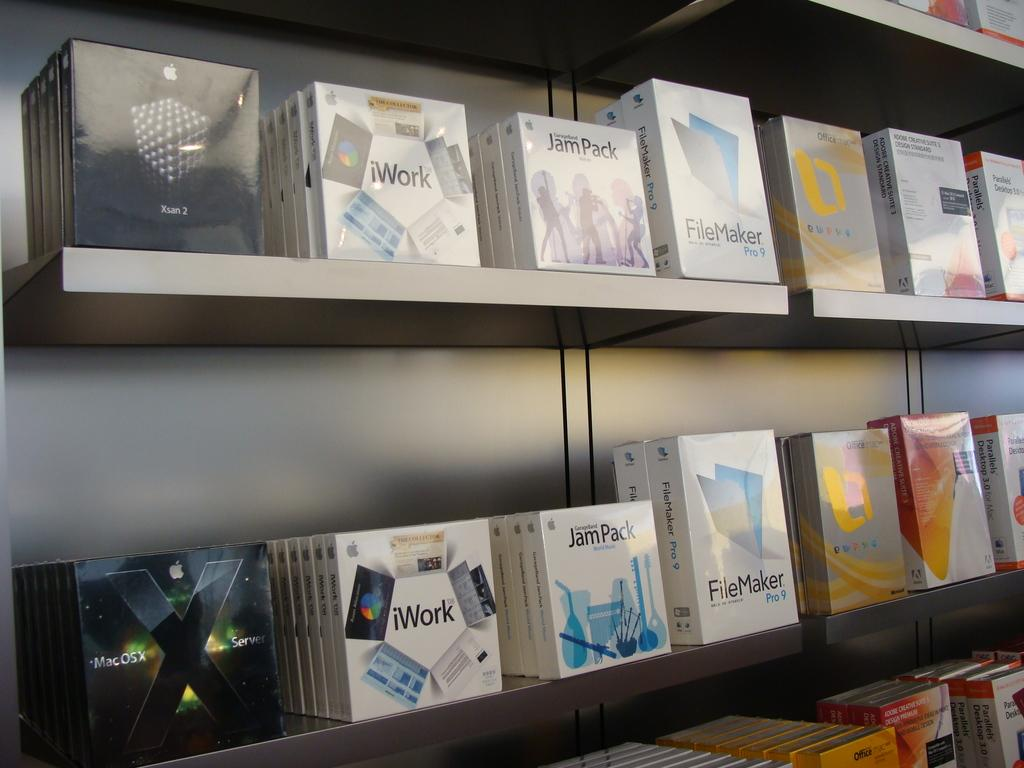<image>
Share a concise interpretation of the image provided. three shelves with lots of iwork csd on the shelf 